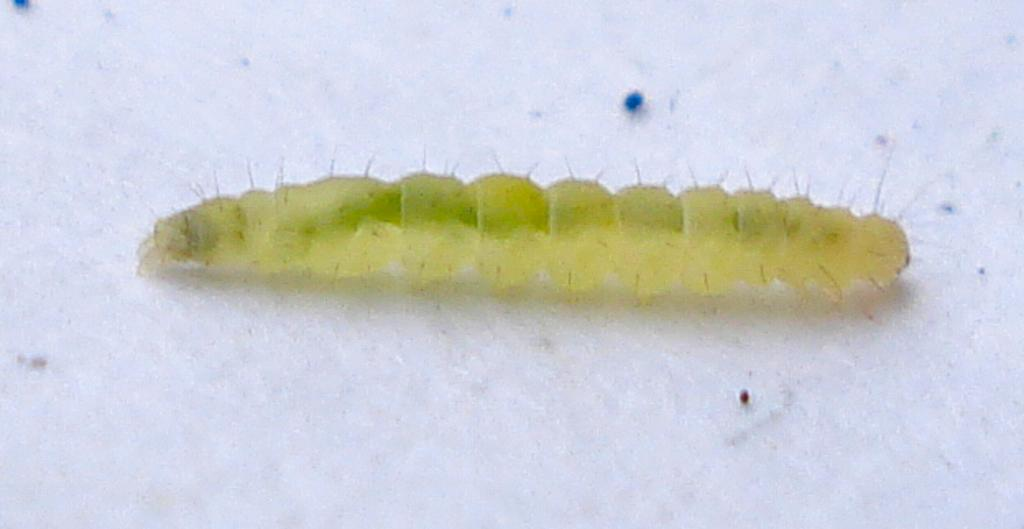What type of creature is present in the image? There is an insect in the image. Can you describe the surface on which the insect is located? The insect is on a white surface. What division of mathematics is the insect using to solve problems in the image? The insect is not using any division of mathematics to solve problems in the image, as insects do not have the cognitive ability to perform mathematical operations. 